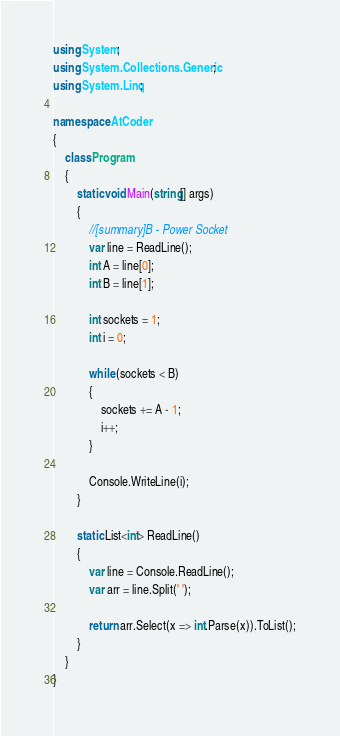Convert code to text. <code><loc_0><loc_0><loc_500><loc_500><_C#_>using System;
using System.Collections.Generic;
using System.Linq;

namespace AtCoder
{
    class Program
    {
        static void Main(string[] args)
        {
            //[summary]B - Power Socket
            var line = ReadLine();
            int A = line[0];
            int B = line[1];

            int sockets = 1;
            int i = 0;

            while (sockets < B)
            {
                sockets += A - 1;
                i++;
            }

            Console.WriteLine(i);
        }

        static List<int> ReadLine()
        {
            var line = Console.ReadLine();
            var arr = line.Split(' ');

            return arr.Select(x => int.Parse(x)).ToList();
        }
    }
}
</code> 